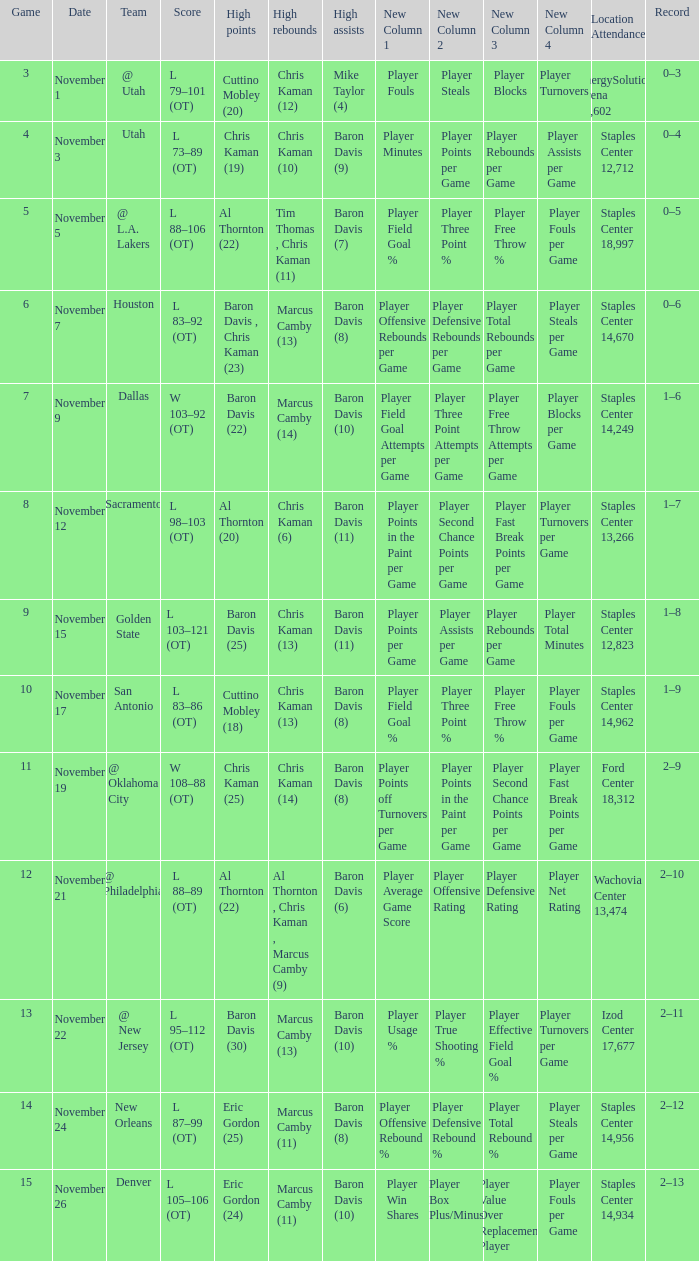Name the high assists for  l 98–103 (ot) Baron Davis (11). 